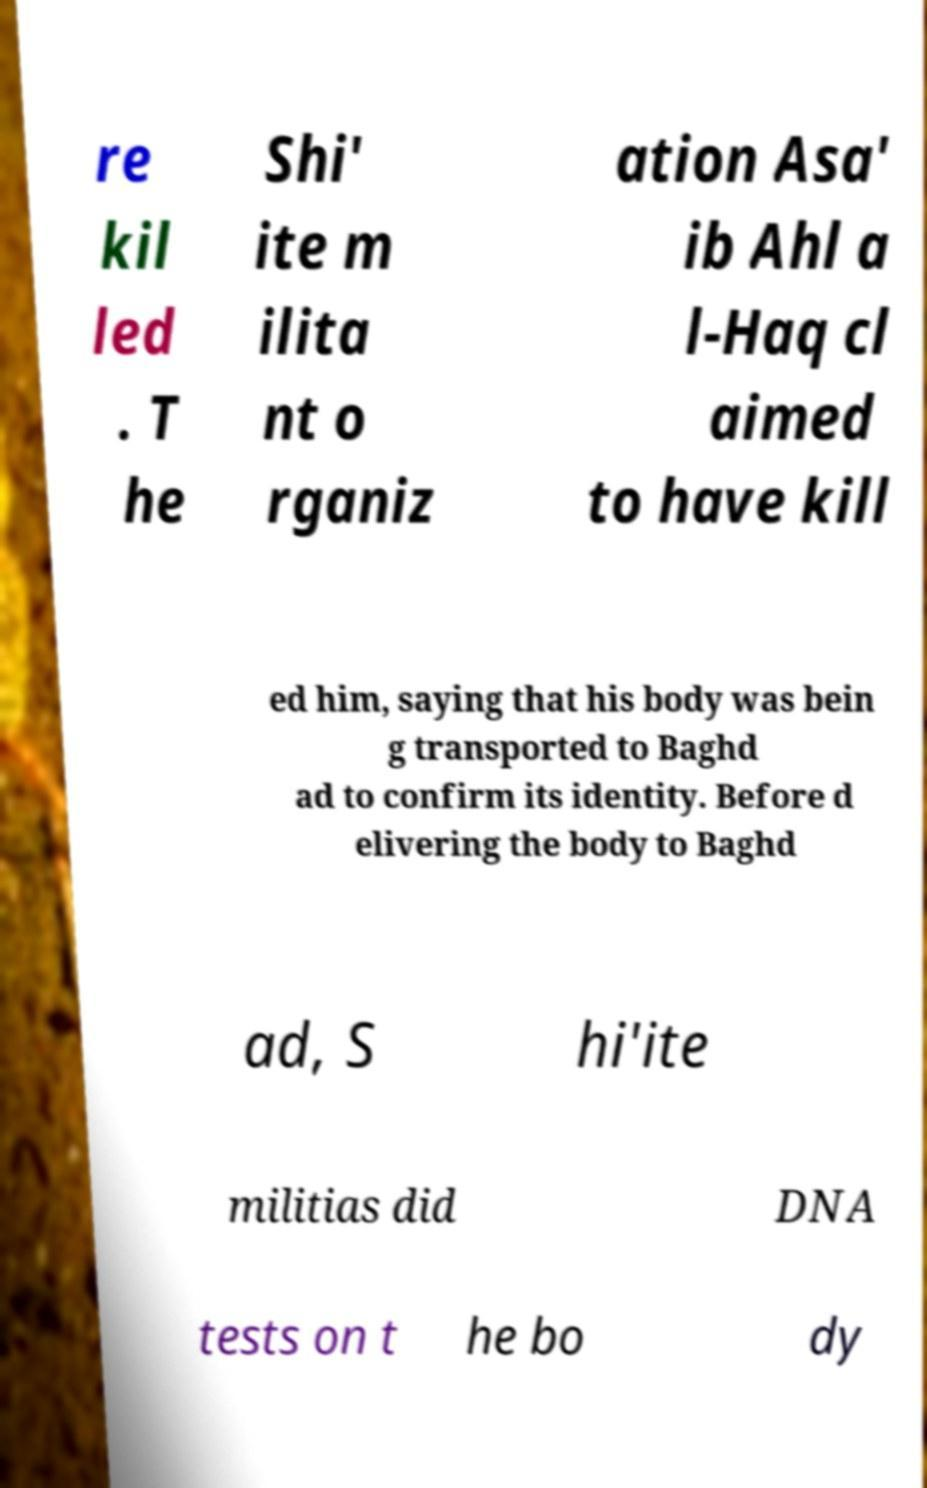Could you assist in decoding the text presented in this image and type it out clearly? re kil led . T he Shi' ite m ilita nt o rganiz ation Asa' ib Ahl a l-Haq cl aimed to have kill ed him, saying that his body was bein g transported to Baghd ad to confirm its identity. Before d elivering the body to Baghd ad, S hi'ite militias did DNA tests on t he bo dy 